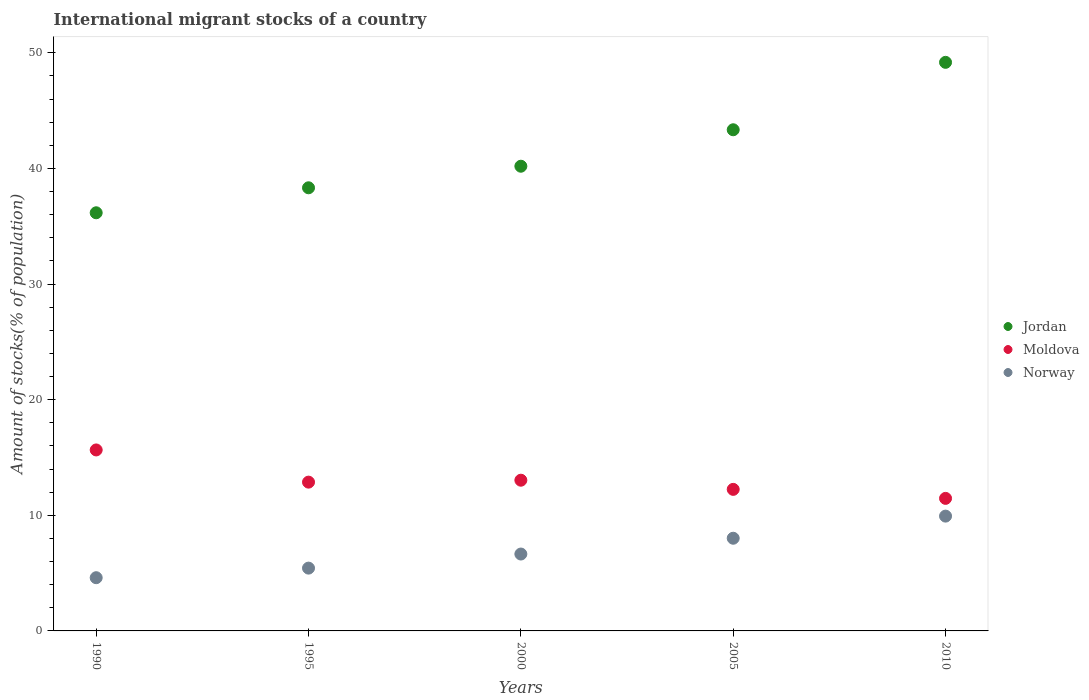What is the amount of stocks in in Jordan in 1995?
Your answer should be compact. 38.32. Across all years, what is the maximum amount of stocks in in Moldova?
Offer a very short reply. 15.65. Across all years, what is the minimum amount of stocks in in Norway?
Your answer should be compact. 4.6. In which year was the amount of stocks in in Jordan maximum?
Your answer should be compact. 2010. What is the total amount of stocks in in Moldova in the graph?
Your response must be concise. 65.26. What is the difference between the amount of stocks in in Moldova in 1990 and that in 2005?
Give a very brief answer. 3.41. What is the difference between the amount of stocks in in Jordan in 2000 and the amount of stocks in in Norway in 2005?
Your answer should be compact. 32.17. What is the average amount of stocks in in Norway per year?
Ensure brevity in your answer.  6.93. In the year 2000, what is the difference between the amount of stocks in in Moldova and amount of stocks in in Norway?
Ensure brevity in your answer.  6.38. In how many years, is the amount of stocks in in Jordan greater than 38 %?
Make the answer very short. 4. What is the ratio of the amount of stocks in in Jordan in 1995 to that in 2005?
Make the answer very short. 0.88. What is the difference between the highest and the second highest amount of stocks in in Jordan?
Provide a succinct answer. 5.83. What is the difference between the highest and the lowest amount of stocks in in Norway?
Your answer should be very brief. 5.33. Does the amount of stocks in in Jordan monotonically increase over the years?
Give a very brief answer. Yes. Is the amount of stocks in in Jordan strictly less than the amount of stocks in in Moldova over the years?
Your answer should be compact. No. How many years are there in the graph?
Keep it short and to the point. 5. What is the difference between two consecutive major ticks on the Y-axis?
Your response must be concise. 10. How many legend labels are there?
Make the answer very short. 3. What is the title of the graph?
Provide a succinct answer. International migrant stocks of a country. Does "Mauritius" appear as one of the legend labels in the graph?
Keep it short and to the point. No. What is the label or title of the X-axis?
Give a very brief answer. Years. What is the label or title of the Y-axis?
Offer a terse response. Amount of stocks(% of population). What is the Amount of stocks(% of population) of Jordan in 1990?
Provide a short and direct response. 36.16. What is the Amount of stocks(% of population) of Moldova in 1990?
Provide a succinct answer. 15.65. What is the Amount of stocks(% of population) of Norway in 1990?
Give a very brief answer. 4.6. What is the Amount of stocks(% of population) in Jordan in 1995?
Offer a terse response. 38.32. What is the Amount of stocks(% of population) of Moldova in 1995?
Your response must be concise. 12.87. What is the Amount of stocks(% of population) of Norway in 1995?
Your response must be concise. 5.43. What is the Amount of stocks(% of population) in Jordan in 2000?
Your answer should be compact. 40.19. What is the Amount of stocks(% of population) of Moldova in 2000?
Ensure brevity in your answer.  13.03. What is the Amount of stocks(% of population) in Norway in 2000?
Your answer should be compact. 6.65. What is the Amount of stocks(% of population) in Jordan in 2005?
Your answer should be compact. 43.34. What is the Amount of stocks(% of population) in Moldova in 2005?
Provide a succinct answer. 12.24. What is the Amount of stocks(% of population) of Norway in 2005?
Offer a terse response. 8.02. What is the Amount of stocks(% of population) in Jordan in 2010?
Your answer should be very brief. 49.17. What is the Amount of stocks(% of population) in Moldova in 2010?
Give a very brief answer. 11.46. What is the Amount of stocks(% of population) of Norway in 2010?
Your answer should be very brief. 9.93. Across all years, what is the maximum Amount of stocks(% of population) of Jordan?
Ensure brevity in your answer.  49.17. Across all years, what is the maximum Amount of stocks(% of population) of Moldova?
Offer a very short reply. 15.65. Across all years, what is the maximum Amount of stocks(% of population) in Norway?
Provide a short and direct response. 9.93. Across all years, what is the minimum Amount of stocks(% of population) of Jordan?
Ensure brevity in your answer.  36.16. Across all years, what is the minimum Amount of stocks(% of population) in Moldova?
Provide a succinct answer. 11.46. Across all years, what is the minimum Amount of stocks(% of population) of Norway?
Your answer should be compact. 4.6. What is the total Amount of stocks(% of population) of Jordan in the graph?
Keep it short and to the point. 207.19. What is the total Amount of stocks(% of population) in Moldova in the graph?
Your answer should be very brief. 65.26. What is the total Amount of stocks(% of population) in Norway in the graph?
Give a very brief answer. 34.63. What is the difference between the Amount of stocks(% of population) in Jordan in 1990 and that in 1995?
Your response must be concise. -2.16. What is the difference between the Amount of stocks(% of population) in Moldova in 1990 and that in 1995?
Keep it short and to the point. 2.78. What is the difference between the Amount of stocks(% of population) of Norway in 1990 and that in 1995?
Keep it short and to the point. -0.83. What is the difference between the Amount of stocks(% of population) of Jordan in 1990 and that in 2000?
Keep it short and to the point. -4.03. What is the difference between the Amount of stocks(% of population) in Moldova in 1990 and that in 2000?
Ensure brevity in your answer.  2.62. What is the difference between the Amount of stocks(% of population) in Norway in 1990 and that in 2000?
Provide a succinct answer. -2.05. What is the difference between the Amount of stocks(% of population) in Jordan in 1990 and that in 2005?
Provide a short and direct response. -7.18. What is the difference between the Amount of stocks(% of population) of Moldova in 1990 and that in 2005?
Make the answer very short. 3.41. What is the difference between the Amount of stocks(% of population) in Norway in 1990 and that in 2005?
Your answer should be very brief. -3.41. What is the difference between the Amount of stocks(% of population) in Jordan in 1990 and that in 2010?
Make the answer very short. -13.01. What is the difference between the Amount of stocks(% of population) in Moldova in 1990 and that in 2010?
Your response must be concise. 4.19. What is the difference between the Amount of stocks(% of population) in Norway in 1990 and that in 2010?
Provide a succinct answer. -5.33. What is the difference between the Amount of stocks(% of population) of Jordan in 1995 and that in 2000?
Your answer should be compact. -1.87. What is the difference between the Amount of stocks(% of population) in Moldova in 1995 and that in 2000?
Give a very brief answer. -0.17. What is the difference between the Amount of stocks(% of population) of Norway in 1995 and that in 2000?
Give a very brief answer. -1.22. What is the difference between the Amount of stocks(% of population) of Jordan in 1995 and that in 2005?
Ensure brevity in your answer.  -5.02. What is the difference between the Amount of stocks(% of population) of Moldova in 1995 and that in 2005?
Your answer should be very brief. 0.63. What is the difference between the Amount of stocks(% of population) in Norway in 1995 and that in 2005?
Your answer should be very brief. -2.58. What is the difference between the Amount of stocks(% of population) of Jordan in 1995 and that in 2010?
Your response must be concise. -10.85. What is the difference between the Amount of stocks(% of population) in Moldova in 1995 and that in 2010?
Provide a short and direct response. 1.4. What is the difference between the Amount of stocks(% of population) in Norway in 1995 and that in 2010?
Provide a short and direct response. -4.5. What is the difference between the Amount of stocks(% of population) in Jordan in 2000 and that in 2005?
Offer a terse response. -3.15. What is the difference between the Amount of stocks(% of population) in Moldova in 2000 and that in 2005?
Keep it short and to the point. 0.79. What is the difference between the Amount of stocks(% of population) of Norway in 2000 and that in 2005?
Offer a terse response. -1.37. What is the difference between the Amount of stocks(% of population) of Jordan in 2000 and that in 2010?
Your answer should be compact. -8.98. What is the difference between the Amount of stocks(% of population) of Moldova in 2000 and that in 2010?
Your response must be concise. 1.57. What is the difference between the Amount of stocks(% of population) in Norway in 2000 and that in 2010?
Make the answer very short. -3.28. What is the difference between the Amount of stocks(% of population) of Jordan in 2005 and that in 2010?
Make the answer very short. -5.83. What is the difference between the Amount of stocks(% of population) in Moldova in 2005 and that in 2010?
Ensure brevity in your answer.  0.78. What is the difference between the Amount of stocks(% of population) of Norway in 2005 and that in 2010?
Offer a very short reply. -1.91. What is the difference between the Amount of stocks(% of population) in Jordan in 1990 and the Amount of stocks(% of population) in Moldova in 1995?
Offer a terse response. 23.29. What is the difference between the Amount of stocks(% of population) of Jordan in 1990 and the Amount of stocks(% of population) of Norway in 1995?
Make the answer very short. 30.73. What is the difference between the Amount of stocks(% of population) in Moldova in 1990 and the Amount of stocks(% of population) in Norway in 1995?
Ensure brevity in your answer.  10.22. What is the difference between the Amount of stocks(% of population) of Jordan in 1990 and the Amount of stocks(% of population) of Moldova in 2000?
Ensure brevity in your answer.  23.13. What is the difference between the Amount of stocks(% of population) in Jordan in 1990 and the Amount of stocks(% of population) in Norway in 2000?
Give a very brief answer. 29.51. What is the difference between the Amount of stocks(% of population) in Moldova in 1990 and the Amount of stocks(% of population) in Norway in 2000?
Your response must be concise. 9. What is the difference between the Amount of stocks(% of population) of Jordan in 1990 and the Amount of stocks(% of population) of Moldova in 2005?
Offer a terse response. 23.92. What is the difference between the Amount of stocks(% of population) of Jordan in 1990 and the Amount of stocks(% of population) of Norway in 2005?
Keep it short and to the point. 28.15. What is the difference between the Amount of stocks(% of population) of Moldova in 1990 and the Amount of stocks(% of population) of Norway in 2005?
Offer a very short reply. 7.64. What is the difference between the Amount of stocks(% of population) of Jordan in 1990 and the Amount of stocks(% of population) of Moldova in 2010?
Make the answer very short. 24.7. What is the difference between the Amount of stocks(% of population) in Jordan in 1990 and the Amount of stocks(% of population) in Norway in 2010?
Your response must be concise. 26.23. What is the difference between the Amount of stocks(% of population) of Moldova in 1990 and the Amount of stocks(% of population) of Norway in 2010?
Keep it short and to the point. 5.72. What is the difference between the Amount of stocks(% of population) in Jordan in 1995 and the Amount of stocks(% of population) in Moldova in 2000?
Give a very brief answer. 25.29. What is the difference between the Amount of stocks(% of population) of Jordan in 1995 and the Amount of stocks(% of population) of Norway in 2000?
Give a very brief answer. 31.67. What is the difference between the Amount of stocks(% of population) in Moldova in 1995 and the Amount of stocks(% of population) in Norway in 2000?
Offer a very short reply. 6.22. What is the difference between the Amount of stocks(% of population) in Jordan in 1995 and the Amount of stocks(% of population) in Moldova in 2005?
Offer a terse response. 26.08. What is the difference between the Amount of stocks(% of population) of Jordan in 1995 and the Amount of stocks(% of population) of Norway in 2005?
Make the answer very short. 30.31. What is the difference between the Amount of stocks(% of population) in Moldova in 1995 and the Amount of stocks(% of population) in Norway in 2005?
Provide a succinct answer. 4.85. What is the difference between the Amount of stocks(% of population) of Jordan in 1995 and the Amount of stocks(% of population) of Moldova in 2010?
Offer a very short reply. 26.86. What is the difference between the Amount of stocks(% of population) in Jordan in 1995 and the Amount of stocks(% of population) in Norway in 2010?
Ensure brevity in your answer.  28.39. What is the difference between the Amount of stocks(% of population) of Moldova in 1995 and the Amount of stocks(% of population) of Norway in 2010?
Offer a very short reply. 2.94. What is the difference between the Amount of stocks(% of population) of Jordan in 2000 and the Amount of stocks(% of population) of Moldova in 2005?
Your answer should be very brief. 27.95. What is the difference between the Amount of stocks(% of population) of Jordan in 2000 and the Amount of stocks(% of population) of Norway in 2005?
Provide a succinct answer. 32.17. What is the difference between the Amount of stocks(% of population) in Moldova in 2000 and the Amount of stocks(% of population) in Norway in 2005?
Make the answer very short. 5.02. What is the difference between the Amount of stocks(% of population) in Jordan in 2000 and the Amount of stocks(% of population) in Moldova in 2010?
Give a very brief answer. 28.73. What is the difference between the Amount of stocks(% of population) of Jordan in 2000 and the Amount of stocks(% of population) of Norway in 2010?
Offer a very short reply. 30.26. What is the difference between the Amount of stocks(% of population) in Moldova in 2000 and the Amount of stocks(% of population) in Norway in 2010?
Your response must be concise. 3.11. What is the difference between the Amount of stocks(% of population) of Jordan in 2005 and the Amount of stocks(% of population) of Moldova in 2010?
Provide a succinct answer. 31.88. What is the difference between the Amount of stocks(% of population) of Jordan in 2005 and the Amount of stocks(% of population) of Norway in 2010?
Make the answer very short. 33.41. What is the difference between the Amount of stocks(% of population) of Moldova in 2005 and the Amount of stocks(% of population) of Norway in 2010?
Offer a very short reply. 2.31. What is the average Amount of stocks(% of population) in Jordan per year?
Make the answer very short. 41.44. What is the average Amount of stocks(% of population) in Moldova per year?
Your response must be concise. 13.05. What is the average Amount of stocks(% of population) in Norway per year?
Offer a terse response. 6.93. In the year 1990, what is the difference between the Amount of stocks(% of population) of Jordan and Amount of stocks(% of population) of Moldova?
Your response must be concise. 20.51. In the year 1990, what is the difference between the Amount of stocks(% of population) in Jordan and Amount of stocks(% of population) in Norway?
Offer a terse response. 31.56. In the year 1990, what is the difference between the Amount of stocks(% of population) of Moldova and Amount of stocks(% of population) of Norway?
Keep it short and to the point. 11.05. In the year 1995, what is the difference between the Amount of stocks(% of population) in Jordan and Amount of stocks(% of population) in Moldova?
Your answer should be compact. 25.46. In the year 1995, what is the difference between the Amount of stocks(% of population) of Jordan and Amount of stocks(% of population) of Norway?
Make the answer very short. 32.89. In the year 1995, what is the difference between the Amount of stocks(% of population) of Moldova and Amount of stocks(% of population) of Norway?
Make the answer very short. 7.44. In the year 2000, what is the difference between the Amount of stocks(% of population) of Jordan and Amount of stocks(% of population) of Moldova?
Provide a succinct answer. 27.15. In the year 2000, what is the difference between the Amount of stocks(% of population) in Jordan and Amount of stocks(% of population) in Norway?
Your answer should be very brief. 33.54. In the year 2000, what is the difference between the Amount of stocks(% of population) of Moldova and Amount of stocks(% of population) of Norway?
Provide a succinct answer. 6.38. In the year 2005, what is the difference between the Amount of stocks(% of population) in Jordan and Amount of stocks(% of population) in Moldova?
Give a very brief answer. 31.1. In the year 2005, what is the difference between the Amount of stocks(% of population) in Jordan and Amount of stocks(% of population) in Norway?
Offer a terse response. 35.33. In the year 2005, what is the difference between the Amount of stocks(% of population) of Moldova and Amount of stocks(% of population) of Norway?
Provide a short and direct response. 4.23. In the year 2010, what is the difference between the Amount of stocks(% of population) in Jordan and Amount of stocks(% of population) in Moldova?
Your answer should be very brief. 37.71. In the year 2010, what is the difference between the Amount of stocks(% of population) of Jordan and Amount of stocks(% of population) of Norway?
Ensure brevity in your answer.  39.24. In the year 2010, what is the difference between the Amount of stocks(% of population) of Moldova and Amount of stocks(% of population) of Norway?
Provide a short and direct response. 1.53. What is the ratio of the Amount of stocks(% of population) in Jordan in 1990 to that in 1995?
Ensure brevity in your answer.  0.94. What is the ratio of the Amount of stocks(% of population) in Moldova in 1990 to that in 1995?
Your answer should be compact. 1.22. What is the ratio of the Amount of stocks(% of population) of Norway in 1990 to that in 1995?
Ensure brevity in your answer.  0.85. What is the ratio of the Amount of stocks(% of population) in Jordan in 1990 to that in 2000?
Ensure brevity in your answer.  0.9. What is the ratio of the Amount of stocks(% of population) in Moldova in 1990 to that in 2000?
Your response must be concise. 1.2. What is the ratio of the Amount of stocks(% of population) of Norway in 1990 to that in 2000?
Offer a terse response. 0.69. What is the ratio of the Amount of stocks(% of population) of Jordan in 1990 to that in 2005?
Give a very brief answer. 0.83. What is the ratio of the Amount of stocks(% of population) in Moldova in 1990 to that in 2005?
Provide a short and direct response. 1.28. What is the ratio of the Amount of stocks(% of population) of Norway in 1990 to that in 2005?
Your answer should be compact. 0.57. What is the ratio of the Amount of stocks(% of population) in Jordan in 1990 to that in 2010?
Your answer should be very brief. 0.74. What is the ratio of the Amount of stocks(% of population) of Moldova in 1990 to that in 2010?
Offer a terse response. 1.37. What is the ratio of the Amount of stocks(% of population) of Norway in 1990 to that in 2010?
Provide a short and direct response. 0.46. What is the ratio of the Amount of stocks(% of population) in Jordan in 1995 to that in 2000?
Make the answer very short. 0.95. What is the ratio of the Amount of stocks(% of population) of Moldova in 1995 to that in 2000?
Offer a very short reply. 0.99. What is the ratio of the Amount of stocks(% of population) in Norway in 1995 to that in 2000?
Make the answer very short. 0.82. What is the ratio of the Amount of stocks(% of population) of Jordan in 1995 to that in 2005?
Ensure brevity in your answer.  0.88. What is the ratio of the Amount of stocks(% of population) of Moldova in 1995 to that in 2005?
Your answer should be compact. 1.05. What is the ratio of the Amount of stocks(% of population) of Norway in 1995 to that in 2005?
Provide a succinct answer. 0.68. What is the ratio of the Amount of stocks(% of population) of Jordan in 1995 to that in 2010?
Provide a short and direct response. 0.78. What is the ratio of the Amount of stocks(% of population) in Moldova in 1995 to that in 2010?
Provide a succinct answer. 1.12. What is the ratio of the Amount of stocks(% of population) in Norway in 1995 to that in 2010?
Your response must be concise. 0.55. What is the ratio of the Amount of stocks(% of population) in Jordan in 2000 to that in 2005?
Make the answer very short. 0.93. What is the ratio of the Amount of stocks(% of population) in Moldova in 2000 to that in 2005?
Provide a succinct answer. 1.06. What is the ratio of the Amount of stocks(% of population) in Norway in 2000 to that in 2005?
Offer a terse response. 0.83. What is the ratio of the Amount of stocks(% of population) of Jordan in 2000 to that in 2010?
Ensure brevity in your answer.  0.82. What is the ratio of the Amount of stocks(% of population) of Moldova in 2000 to that in 2010?
Offer a terse response. 1.14. What is the ratio of the Amount of stocks(% of population) of Norway in 2000 to that in 2010?
Your answer should be very brief. 0.67. What is the ratio of the Amount of stocks(% of population) of Jordan in 2005 to that in 2010?
Give a very brief answer. 0.88. What is the ratio of the Amount of stocks(% of population) in Moldova in 2005 to that in 2010?
Give a very brief answer. 1.07. What is the ratio of the Amount of stocks(% of population) of Norway in 2005 to that in 2010?
Your answer should be very brief. 0.81. What is the difference between the highest and the second highest Amount of stocks(% of population) of Jordan?
Offer a very short reply. 5.83. What is the difference between the highest and the second highest Amount of stocks(% of population) in Moldova?
Your response must be concise. 2.62. What is the difference between the highest and the second highest Amount of stocks(% of population) in Norway?
Make the answer very short. 1.91. What is the difference between the highest and the lowest Amount of stocks(% of population) of Jordan?
Your answer should be compact. 13.01. What is the difference between the highest and the lowest Amount of stocks(% of population) in Moldova?
Your answer should be compact. 4.19. What is the difference between the highest and the lowest Amount of stocks(% of population) in Norway?
Give a very brief answer. 5.33. 